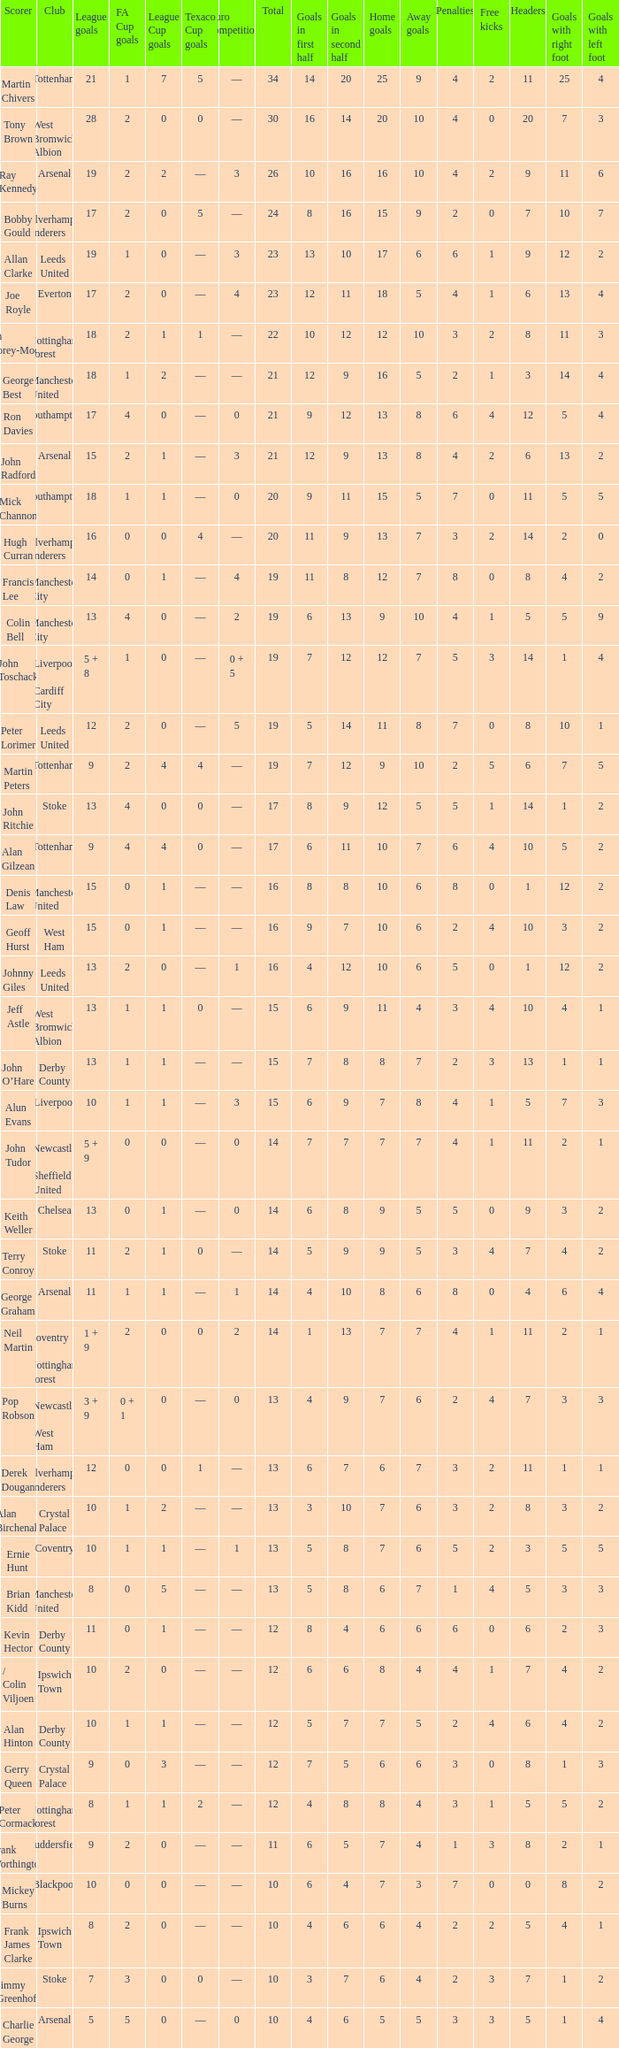What is the average Total, when FA Cup Goals is 1, when League Goals is 10, and when Club is Crystal Palace? 13.0. 